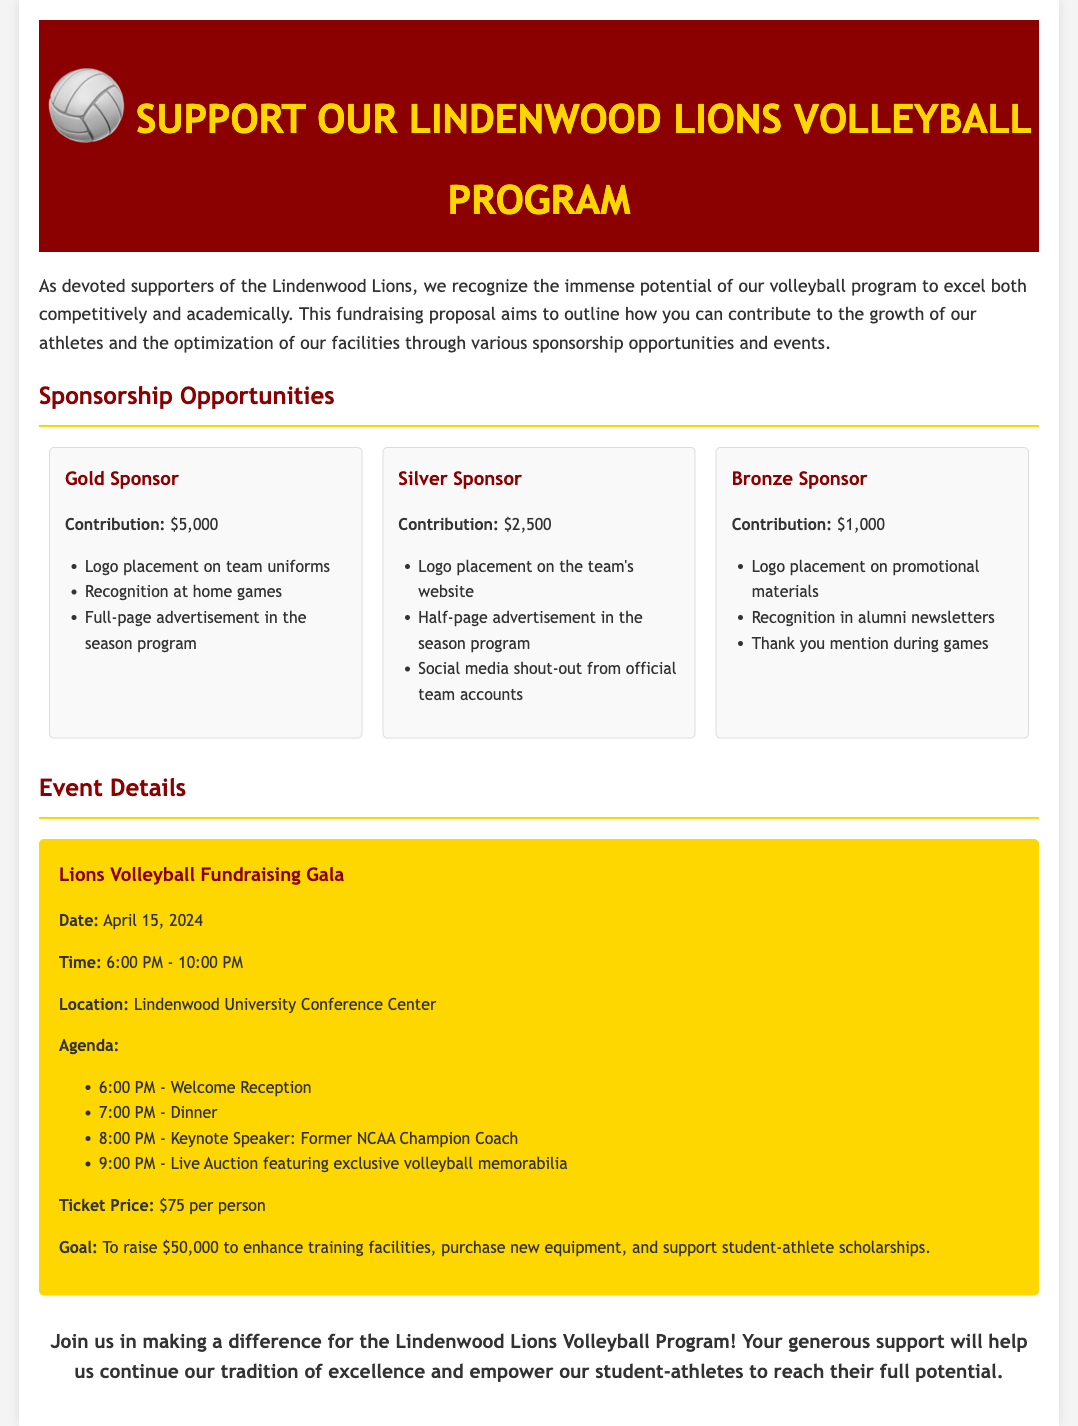What is the contribution amount for a Gold Sponsor? The document specifies the contribution amount for a Gold Sponsor as $5,000.
Answer: $5,000 What date is the Lions Volleyball Fundraising Gala scheduled for? The event details in the document list the date of the gala as April 15, 2024.
Answer: April 15, 2024 How much is the ticket price for the fundraising gala? The document mentions that the ticket price is $75 per person.
Answer: $75 per person What is the goal amount to be raised from the fundraising gala? The document states the goal for the fundraising gala is to raise $50,000.
Answer: $50,000 What recognition will a Bronze Sponsor receive during games? The document indicates that a Bronze Sponsor will receive a thank you mention during games.
Answer: Thank you mention during games What time does the dinner start at the fundraising gala? According to the event agenda in the document, dinner starts at 7:00 PM.
Answer: 7:00 PM What type of speaker will be featured at the gala? The document notes that the keynote speaker will be a Former NCAA Champion Coach.
Answer: Former NCAA Champion Coach What logo placement does a Silver Sponsor receive? The document mentions that a Silver Sponsor receives logo placement on the team's website.
Answer: Logo placement on the team's website What is the location of the Lions Volleyball Fundraising Gala? The event details specify that the location of the gala is the Lindenwood University Conference Center.
Answer: Lindenwood University Conference Center 